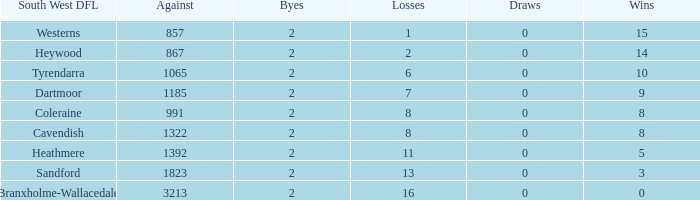Which Losses have a South West DFL of branxholme-wallacedale, and less than 2 Byes? None. 